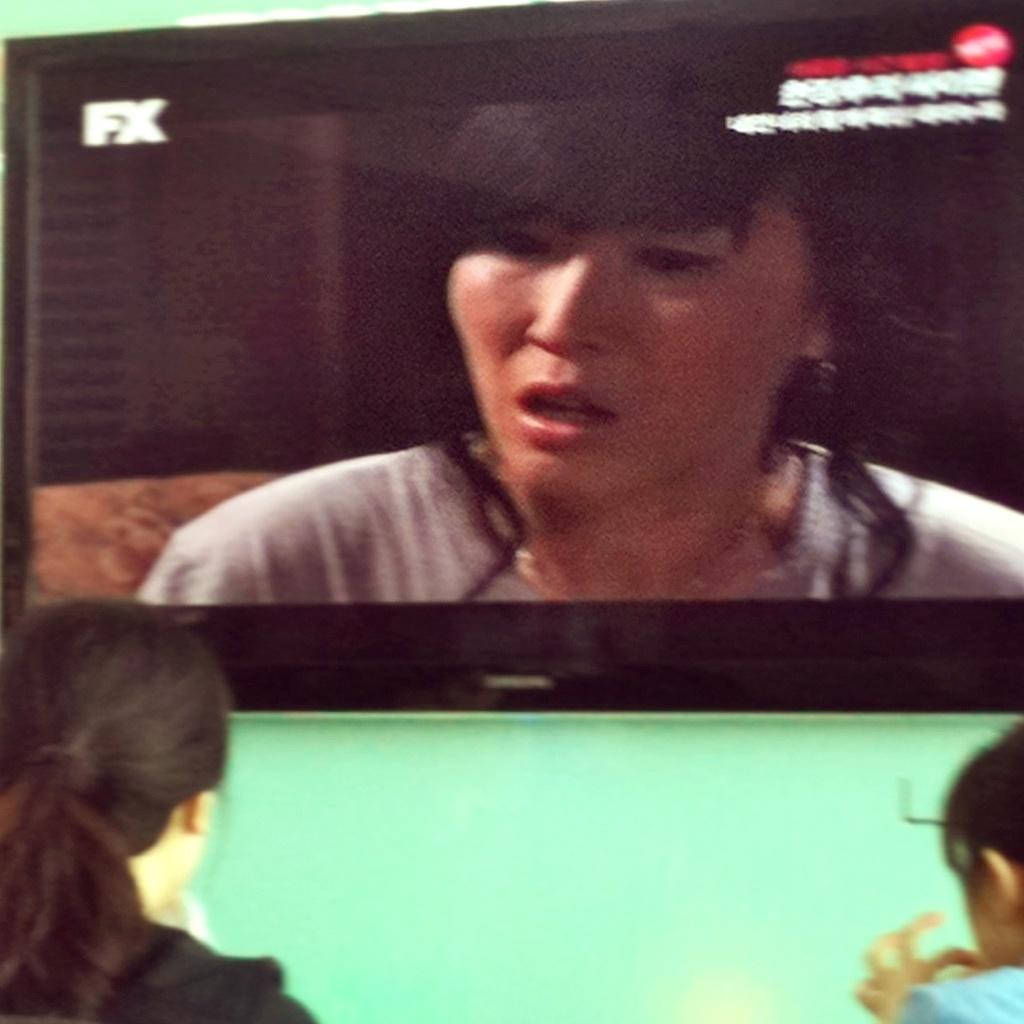Who or what can be seen in the image? There are people in the image. What is on the wall in the image? There is a television on the wall in the image. What is happening on the television screen? A lady is visible on the television screen, and there is some text on the screen. What is the name of the turkey that the lady is holding in the image? There is no turkey present in the image, and the lady is not holding anything. 